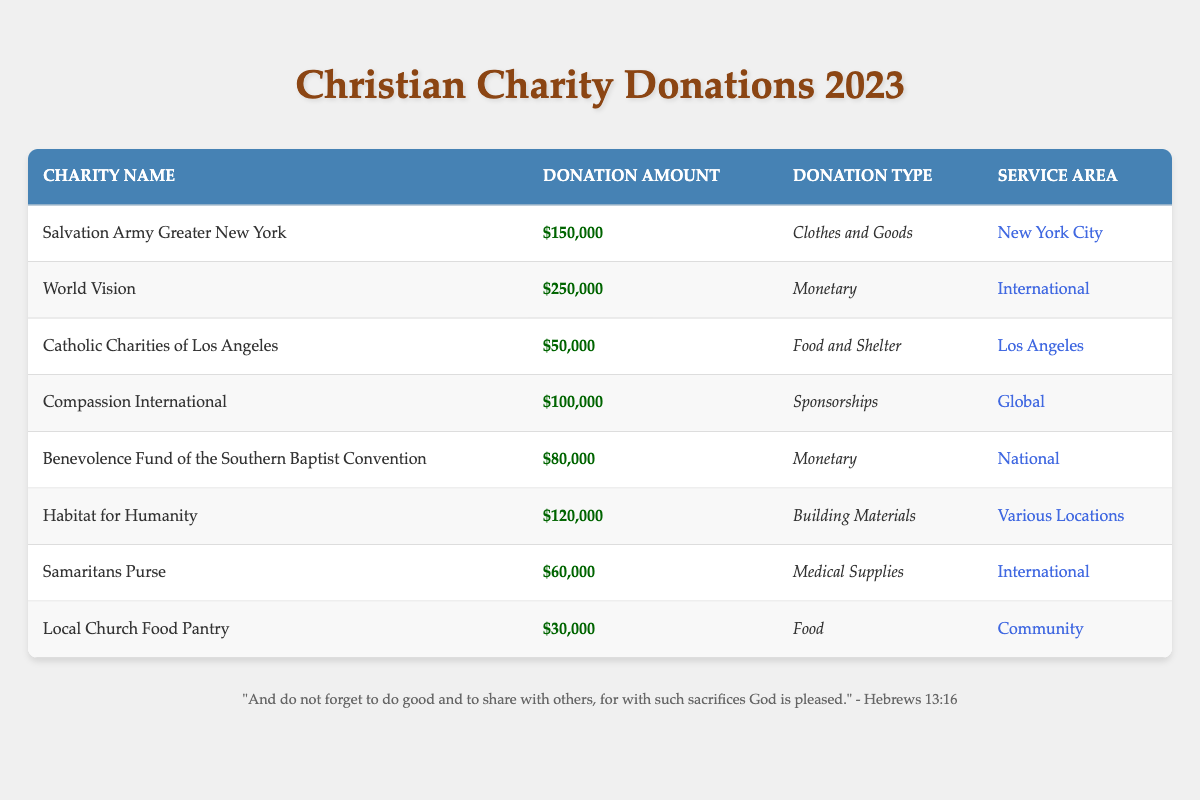What is the total donation amount received by all the charities listed? To find the total donation amount, we need to add together each charity's donation amount: 150000 + 250000 + 50000 + 100000 + 80000 + 120000 + 60000 + 30000 = 450000.
Answer: 450000 Which charity received the highest donation amount? By examining the donation amounts, World Vision received the highest donation of 250000.
Answer: World Vision Is the donation type for the Local Church Food Pantry "Food"? Yes, the Local Church Food Pantry's donation type is listed as "Food" in the table.
Answer: Yes What is the average donation amount for the charities listed? To calculate the average, we first find the total donation (450000), which is divided by the number of charities (8): 450000 / 8 = 56250.
Answer: 56250 Which service area received the least donation amount, and what was that amount? By reviewing the service areas and their donation amounts, Local Church Food Pantry has the least donation amount of 30000.
Answer: Community, 30000 Do any of the charities focus on international service areas? Yes, both World Vision and Samaritans Purse have service areas that are international.
Answer: Yes What is the difference between the highest and lowest donation amounts? The highest donation was from World Vision (250000) and the lowest from Local Church Food Pantry (30000). The difference is 250000 - 30000 = 220000.
Answer: 220000 How many charities provided monetary donations? There are three charities that provided monetary donations: World Vision, Benevolence Fund of the Southern Baptist Convention, and Compassion International.
Answer: 3 